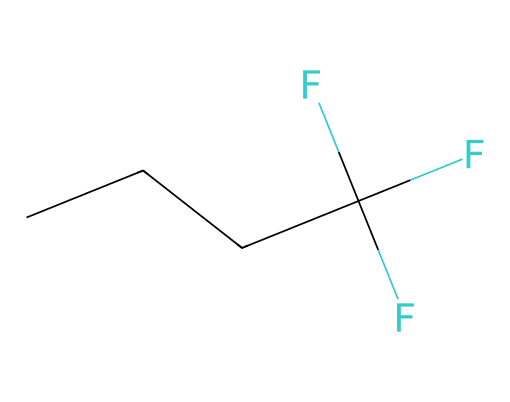What is the molecular formula of this liquid? The SMILES representation indicates the structure of the molecule. "CCCC" refers to four carbon atoms in a straight chain, and "(F)(F)F" indicates three fluorine atoms. Therefore, the molecular formula combines these atoms: C4H6F3.
Answer: C4H6F3 How many carbon atoms are present in this molecule? In the SMILES representation, "CCCC" indicates that there are four continuous carbon atoms.
Answer: 4 What functional group is indicated by the fluorine atoms? The fluorine atoms shown in the SMILES, attached to the carbon chain, indicate the presence of a trifluoromethyl group, a typical feature of many cooling agents to lower boiling point and enhance thermal conductivity.
Answer: trifluoromethyl group How many fluorine atoms are present in the structure? The notation "(F)(F)F" in the SMILES represents three fluorine atoms attached to the carbon chain.
Answer: 3 What is the state of matter for this chemical at room temperature? Given that the compound contains a fluoroalkane structure which typically exhibits liquid properties, this compound is likely a liquid at room temperature. Fluoroalkanes generally have lower boiling points compared to hydrocarbons.
Answer: liquid Why is this chemical useful as a cooling agent in high-performance computers? The presence of fluorine and the molecular structure contributes to low viscosity and high thermal conductivity, which are essential for effective heat transfer in cooling applications. Fluorinated compounds help to efficiently dissipate heat from high-performance components without causing electrical interference.
Answer: low viscosity, high thermal conductivity 